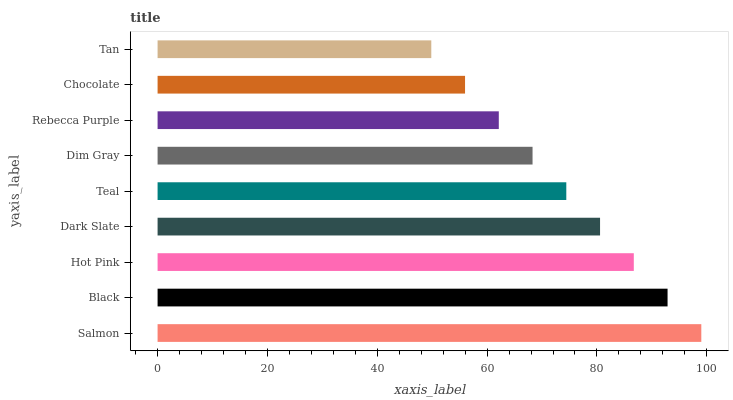Is Tan the minimum?
Answer yes or no. Yes. Is Salmon the maximum?
Answer yes or no. Yes. Is Black the minimum?
Answer yes or no. No. Is Black the maximum?
Answer yes or no. No. Is Salmon greater than Black?
Answer yes or no. Yes. Is Black less than Salmon?
Answer yes or no. Yes. Is Black greater than Salmon?
Answer yes or no. No. Is Salmon less than Black?
Answer yes or no. No. Is Teal the high median?
Answer yes or no. Yes. Is Teal the low median?
Answer yes or no. Yes. Is Tan the high median?
Answer yes or no. No. Is Chocolate the low median?
Answer yes or no. No. 